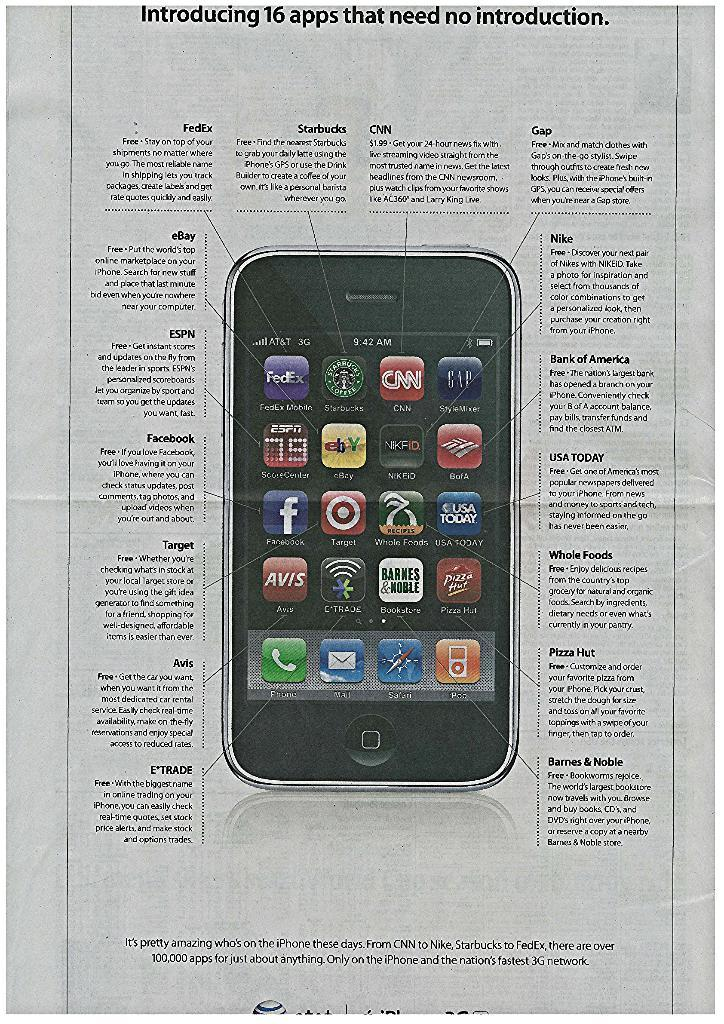Provide a one-sentence caption for the provided image. An ad about a phone that is describing its apps. 